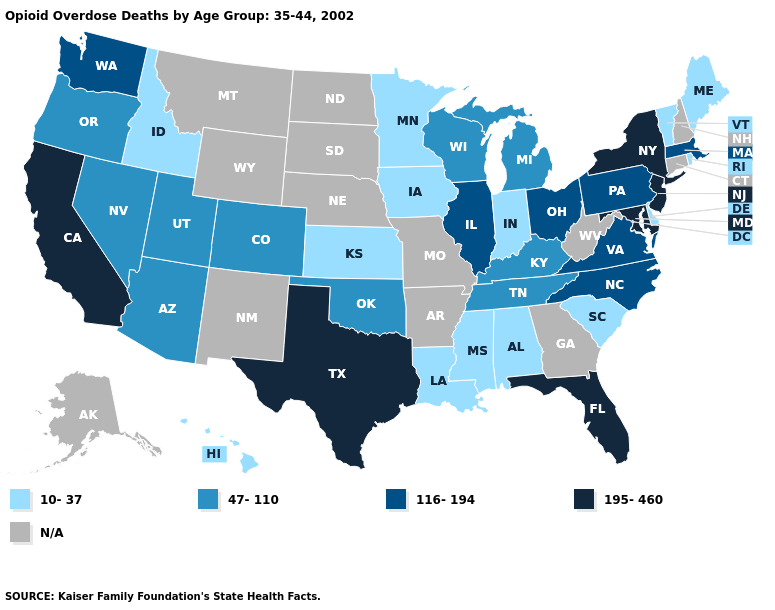Is the legend a continuous bar?
Quick response, please. No. Name the states that have a value in the range 47-110?
Quick response, please. Arizona, Colorado, Kentucky, Michigan, Nevada, Oklahoma, Oregon, Tennessee, Utah, Wisconsin. What is the value of Vermont?
Quick response, please. 10-37. What is the highest value in the USA?
Concise answer only. 195-460. Among the states that border North Dakota , which have the lowest value?
Write a very short answer. Minnesota. Among the states that border Alabama , does Florida have the lowest value?
Write a very short answer. No. Does the first symbol in the legend represent the smallest category?
Quick response, please. Yes. What is the value of Texas?
Keep it brief. 195-460. Does Maine have the lowest value in the Northeast?
Concise answer only. Yes. Name the states that have a value in the range 116-194?
Keep it brief. Illinois, Massachusetts, North Carolina, Ohio, Pennsylvania, Virginia, Washington. Does Pennsylvania have the highest value in the Northeast?
Concise answer only. No. Does New York have the highest value in the USA?
Quick response, please. Yes. Name the states that have a value in the range 47-110?
Quick response, please. Arizona, Colorado, Kentucky, Michigan, Nevada, Oklahoma, Oregon, Tennessee, Utah, Wisconsin. 